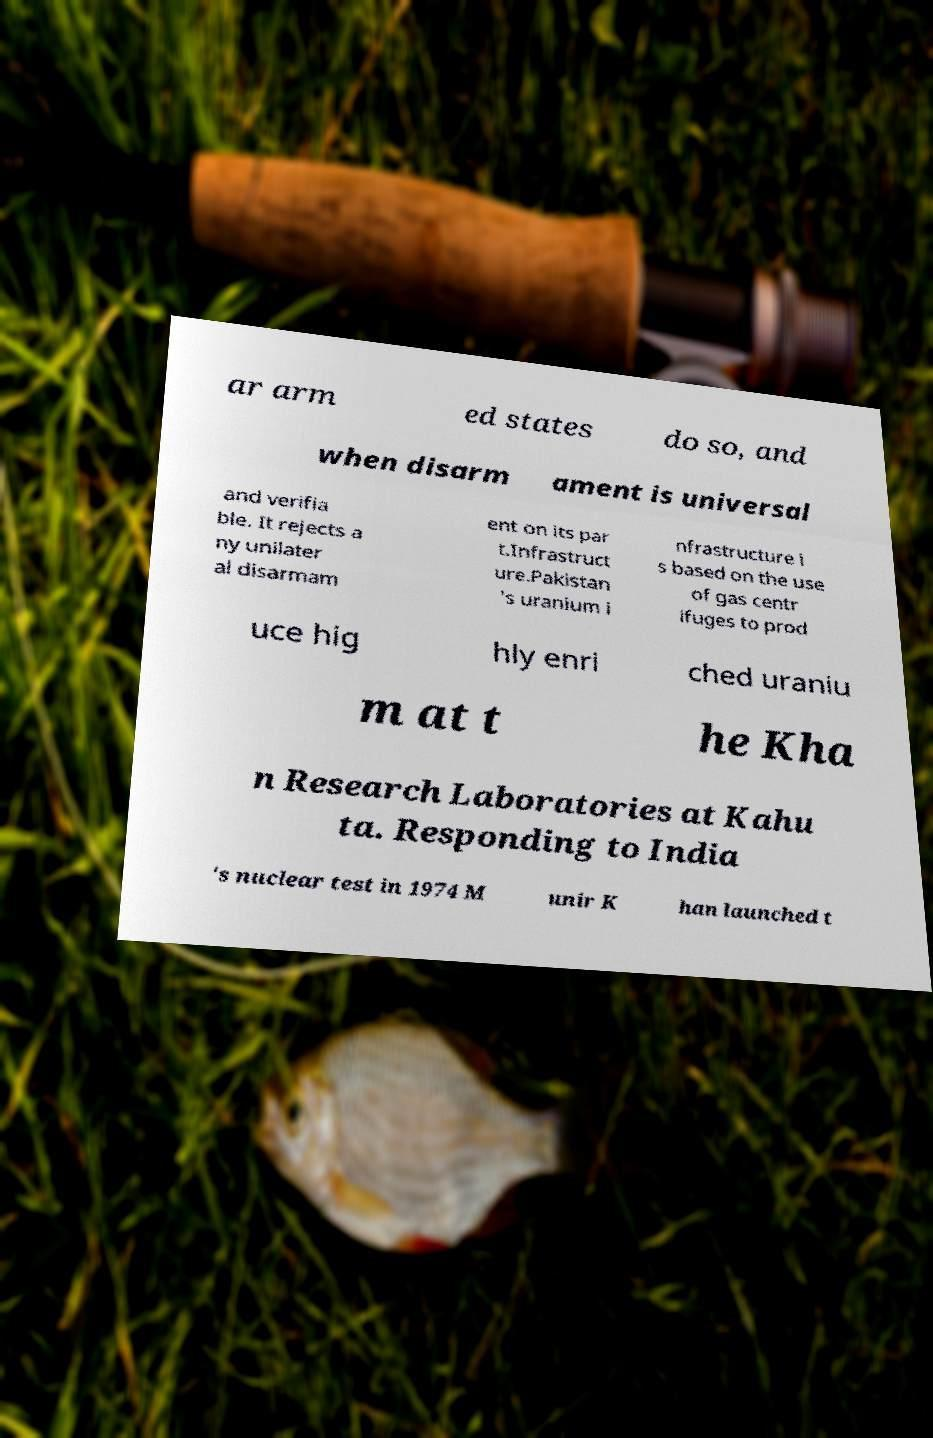Can you read and provide the text displayed in the image?This photo seems to have some interesting text. Can you extract and type it out for me? ar arm ed states do so, and when disarm ament is universal and verifia ble. It rejects a ny unilater al disarmam ent on its par t.Infrastruct ure.Pakistan 's uranium i nfrastructure i s based on the use of gas centr ifuges to prod uce hig hly enri ched uraniu m at t he Kha n Research Laboratories at Kahu ta. Responding to India 's nuclear test in 1974 M unir K han launched t 